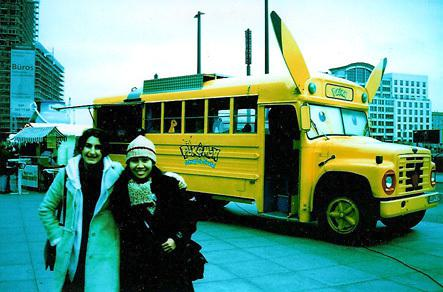What can you infer about the time period or season in this picture? Given the attire of the individuals, with coats and a beanie hat, it appears to be cold weather, suggesting a time in late autumn or winter. The image quality and fashion also hint at a photo that might have been taken in the late 90s to early 2000s. 